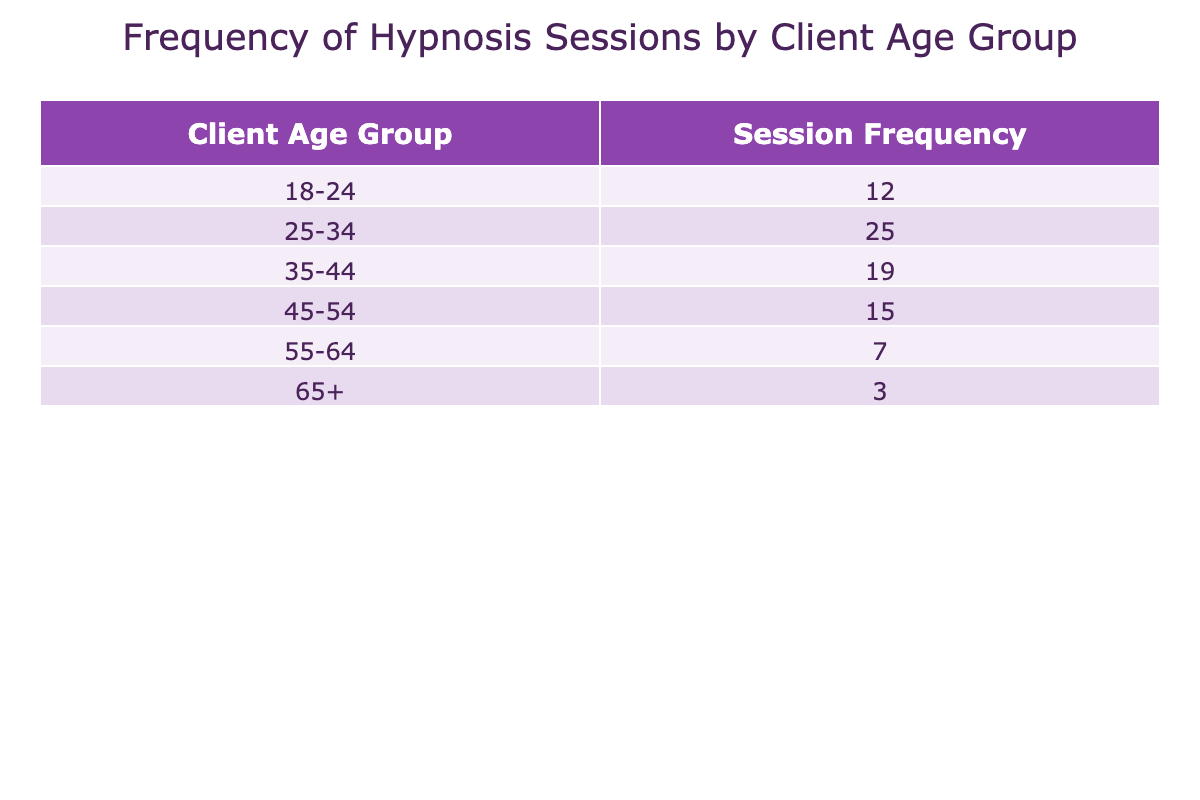What is the session frequency for clients aged 25-34? The table shows that the frequency of sessions for the age group 25-34 is listed under the "Session Frequency" column. The value provided is 25.
Answer: 25 Which age group has the lowest session frequency? By examining the "Session Frequency" column, the age group 65+ has the lowest value, which is 3.
Answer: 65+ What is the total session frequency for clients aged 25 to 54? To find this, sum the frequencies for the age groups 25-34, 35-44, 45-54. The values are 25 (for 25-34), 19 (for 35-44), and 15 (for 45-54), adding up to 25 + 19 + 15 = 59.
Answer: 59 Is the session frequency for clients aged 45-54 greater than that for clients aged 55-64? The session frequency for clients aged 45-54 is 15, while for clients aged 55-64 it is 7. Since 15 is greater than 7, the statement is true.
Answer: Yes What percentage of total sessions does the age group 35-44 represent? First, calculate the total session frequency: 12 + 25 + 19 + 15 + 7 + 3 = 81. Then, find the percentage for 35-44: (19/81) * 100 ≈ 23.46%.
Answer: 23.46% 